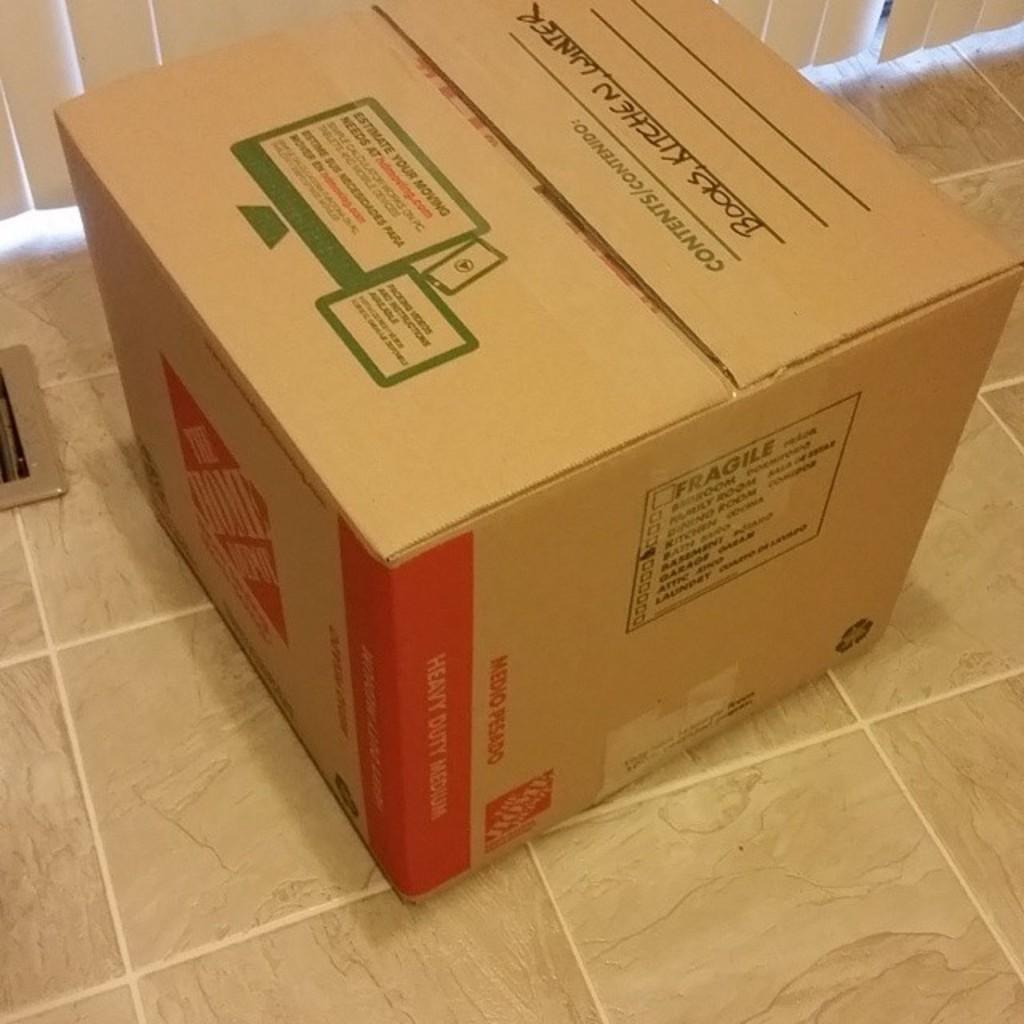<image>
Describe the image concisely. A Home Depot storage box is labeled Books, Kitchen, Winter. 